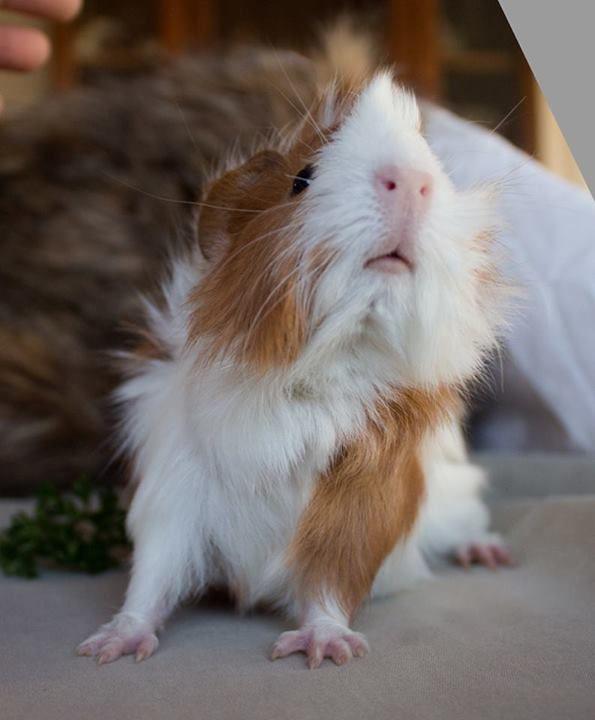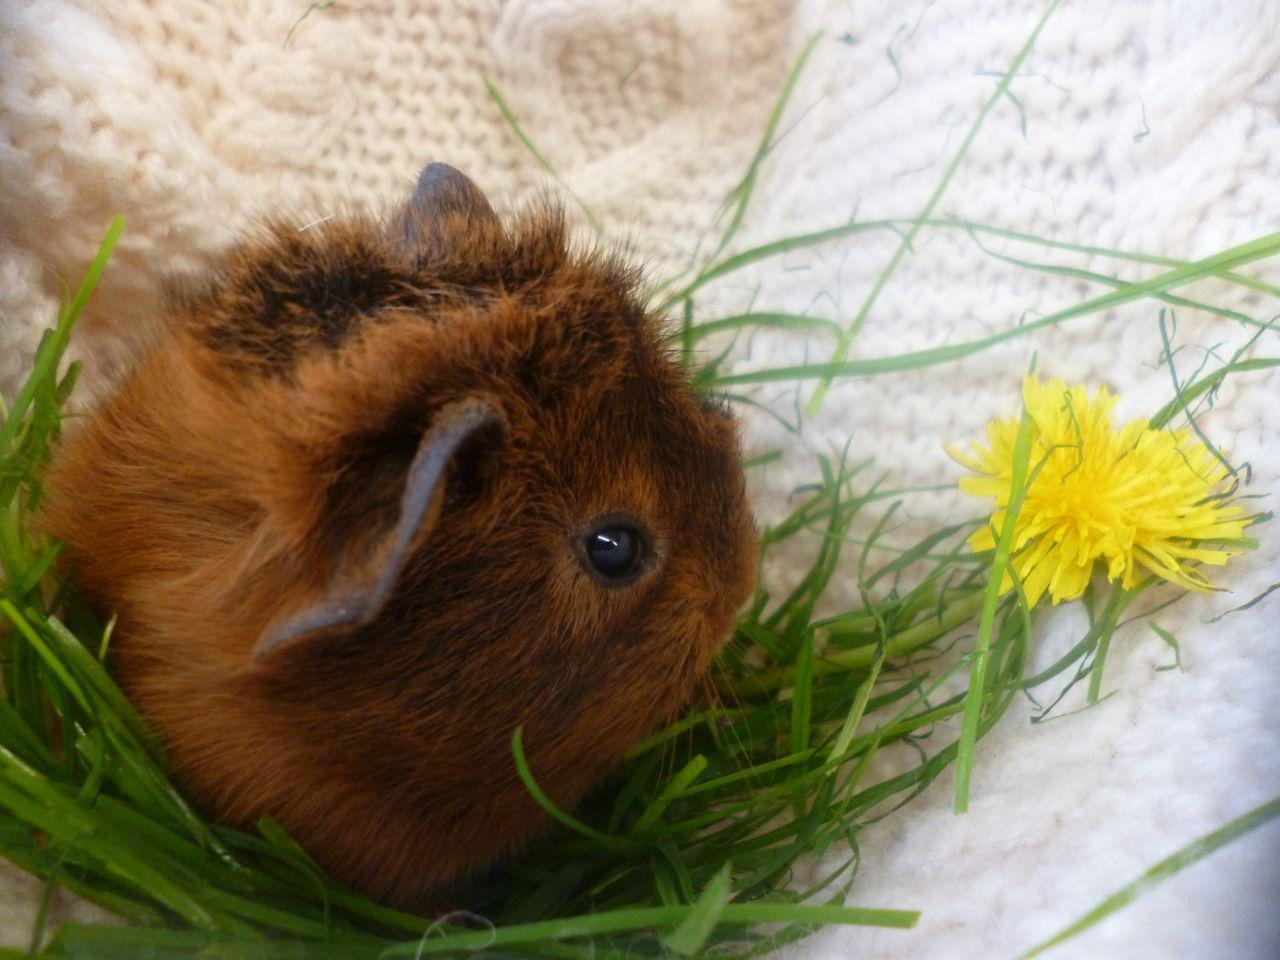The first image is the image on the left, the second image is the image on the right. Examine the images to the left and right. Is the description "There are exactly two guinea pigs in total." accurate? Answer yes or no. Yes. The first image is the image on the left, the second image is the image on the right. For the images displayed, is the sentence "There is at least two rodents in the right image." factually correct? Answer yes or no. No. 